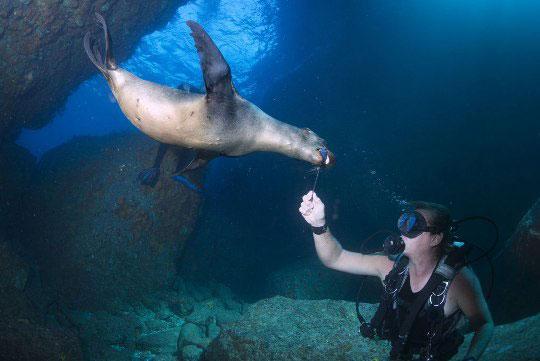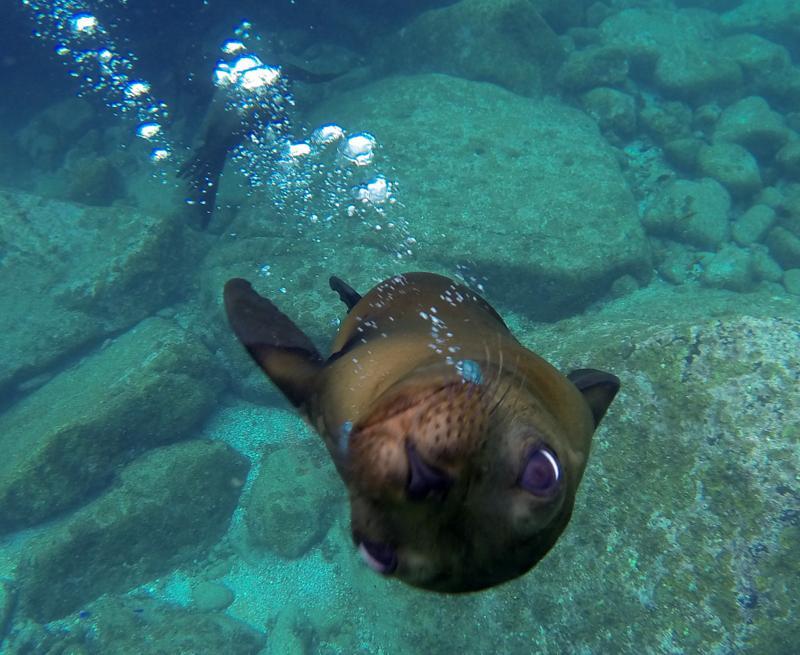The first image is the image on the left, the second image is the image on the right. Examine the images to the left and right. Is the description "An image shows a seal with its nose close to the camera, and no image contains more than one seal in the foreground." accurate? Answer yes or no. Yes. The first image is the image on the left, the second image is the image on the right. For the images displayed, is the sentence "The left image contains no more than one seal." factually correct? Answer yes or no. Yes. 